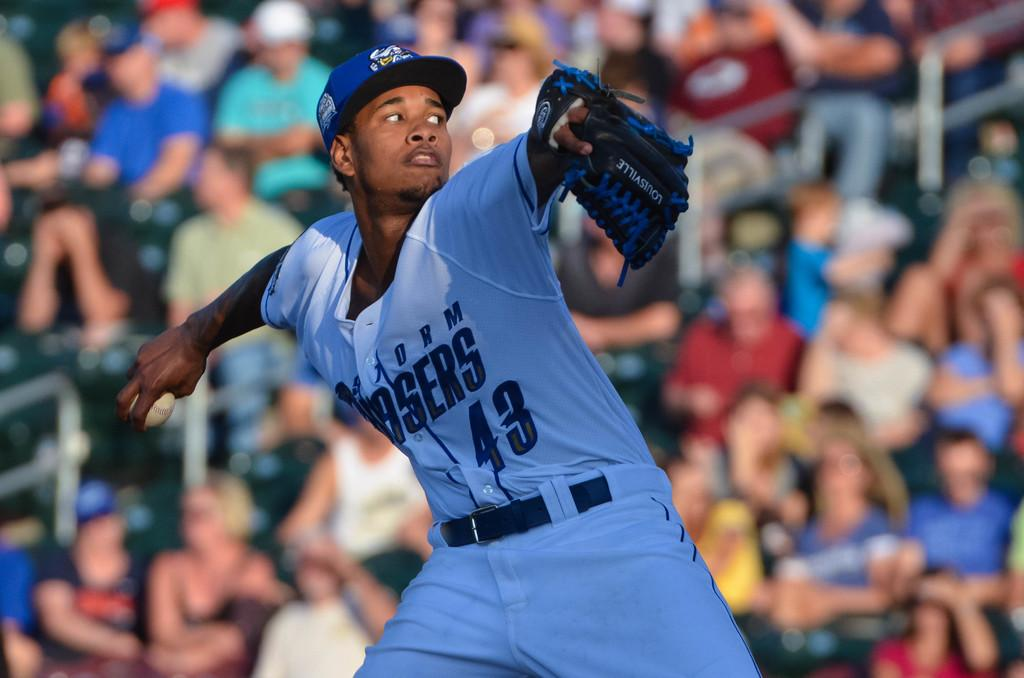Provide a one-sentence caption for the provided image. A baseball player numbered 43 is pitching a ball. 